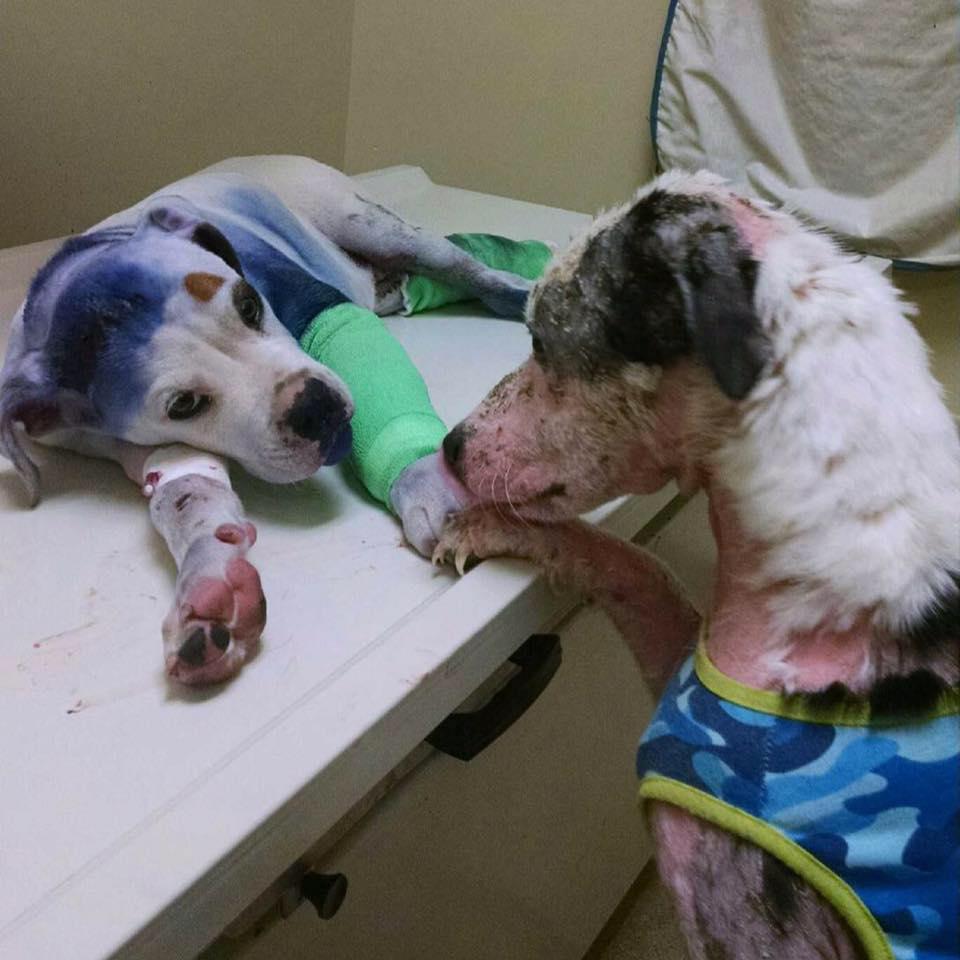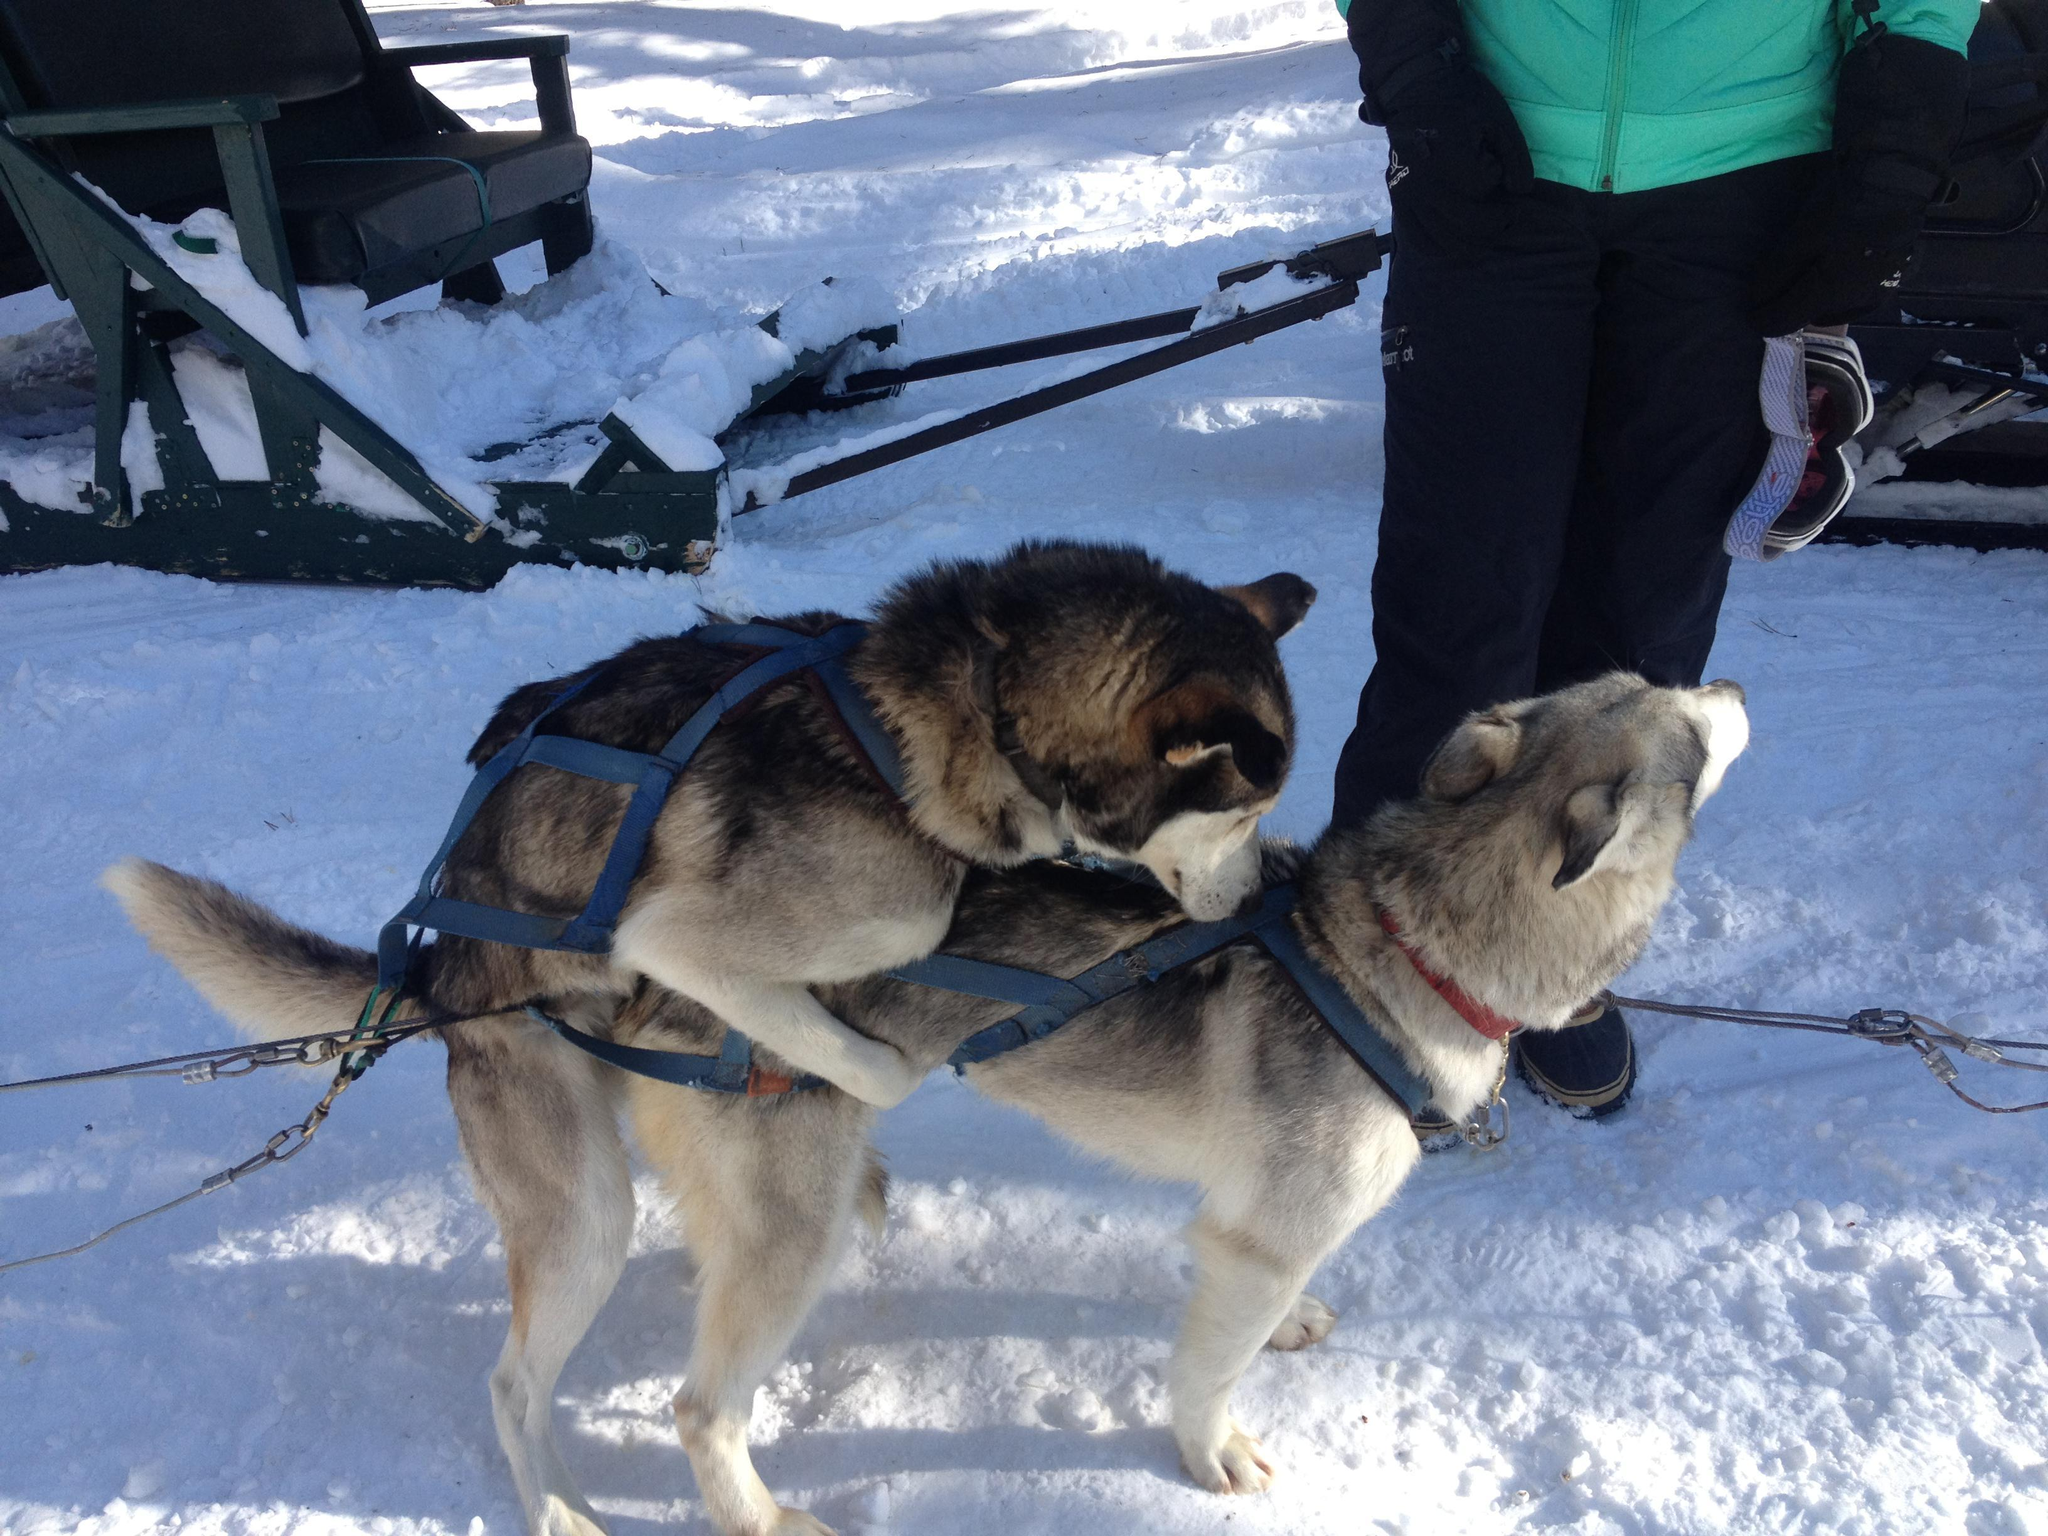The first image is the image on the left, the second image is the image on the right. Evaluate the accuracy of this statement regarding the images: "There is a person wearing camouflage hugging a dog.". Is it true? Answer yes or no. No. The first image is the image on the left, the second image is the image on the right. Given the left and right images, does the statement "One image shows a person in a pony-tail with head bent toward a dog, and the other image shows a male in an olive jacket with head next to a dog." hold true? Answer yes or no. No. 